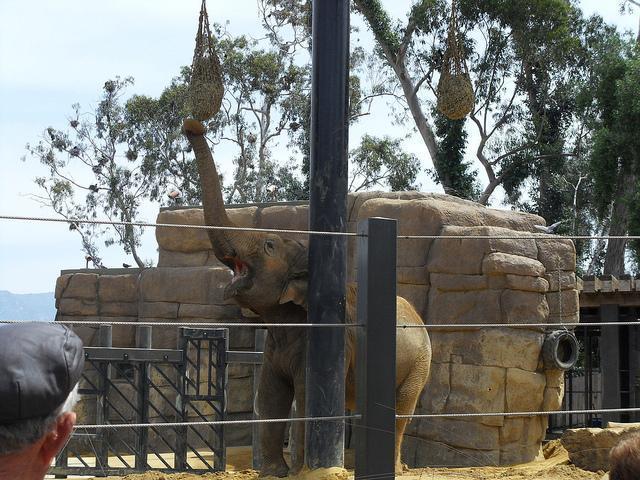How many animals are in this photo?
Give a very brief answer. 1. 